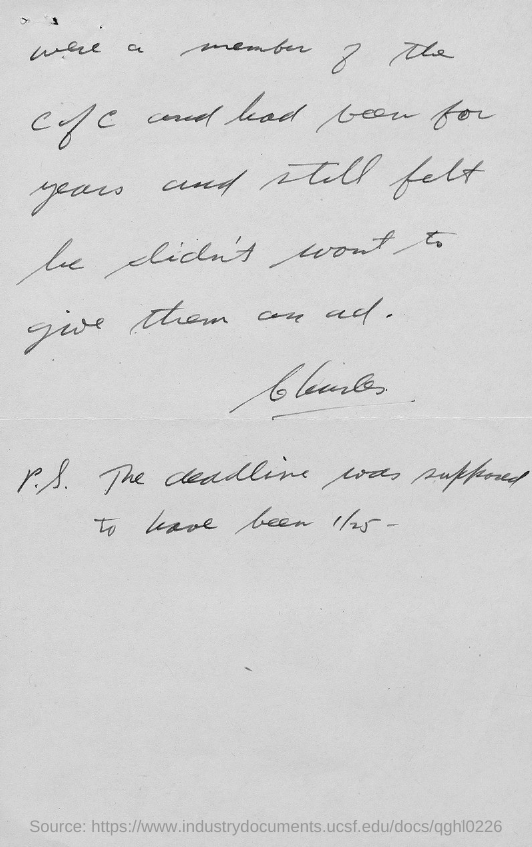What is the number mentioned in the document?
Provide a short and direct response. 1/25. 